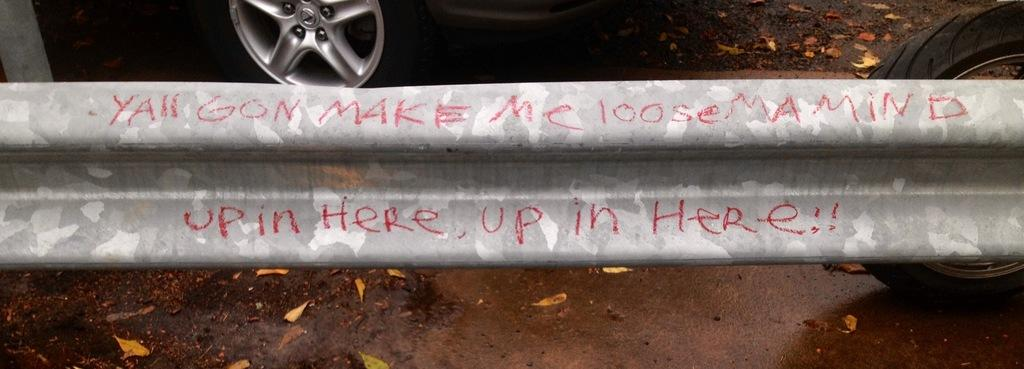What is the main subject in the image? There is a vehicle in the image. What can be seen on the ground in the image? There are leaves on the ground in the image. What is written on a white color surface in the image? There is something written on a white color surface in the image. What year is the pipe mentioned in the image? There is no pipe mentioned in the image, so it is not possible to determine the year. 